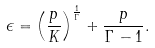Convert formula to latex. <formula><loc_0><loc_0><loc_500><loc_500>\epsilon = \left ( \frac { p } { K } \right ) ^ { \frac { 1 } { \Gamma } } + \frac { p } { \Gamma - 1 } .</formula> 